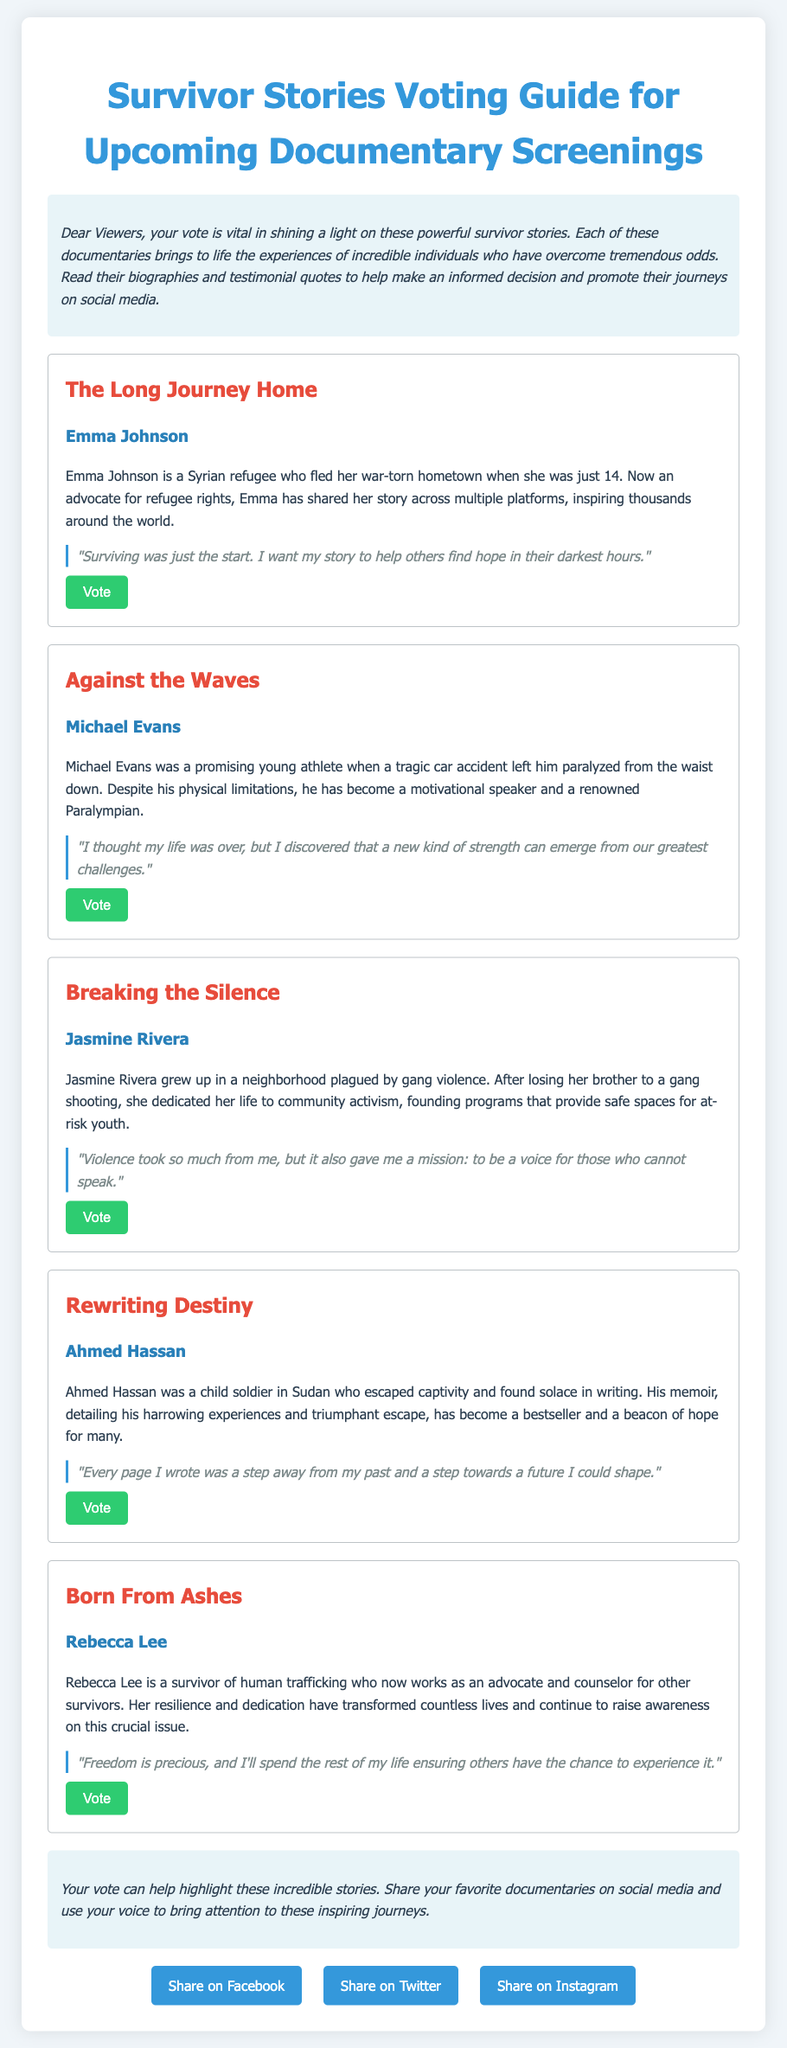What is the title of Emma Johnson's documentary? The title of Emma Johnson's documentary is "The Long Journey Home."
Answer: The Long Journey Home What is Michael Evans' quote? Michael Evans' quote highlights his discovery of strength despite challenges: "I thought my life was over, but I discovered that a new kind of strength can emerge from our greatest challenges."
Answer: "I thought my life was over, but I discovered that a new kind of strength can emerge from our greatest challenges." How many survivor stories are featured in the document? The document features five survivor stories.
Answer: Five What type of advocacy does Rebecca Lee engage in? Rebecca Lee works as an advocate and counselor for other survivors of human trafficking.
Answer: Advocate and counselor What was Ahmed Hassan before becoming a writer? Before becoming a writer, Ahmed Hassan was a child soldier.
Answer: Child soldier Which entry begins with a quote about violence? The entry about Jasmine Rivera begins with a quote about violence: "Violence took so much from me, but it also gave me a mission: to be a voice for those who cannot speak."
Answer: Breaking the Silence 